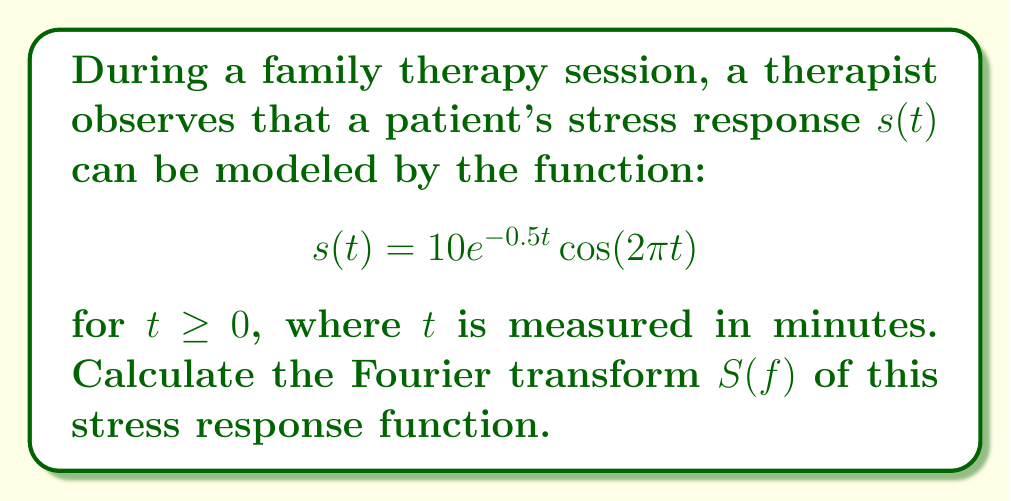Show me your answer to this math problem. To solve this problem, we'll follow these steps:

1) The Fourier transform of a function $s(t)$ is defined as:

   $$S(f) = \int_{-\infty}^{\infty} s(t)e^{-j2\pi ft}dt$$

2) In our case, $s(t)$ is only defined for $t \geq 0$, so we can rewrite the integral as:

   $$S(f) = \int_{0}^{\infty} 10e^{-0.5t}\cos(2\pi t)e^{-j2\pi ft}dt$$

3) We can use Euler's formula to express the cosine term:

   $$\cos(2\pi t) = \frac{1}{2}(e^{j2\pi t} + e^{-j2\pi t})$$

4) Substituting this into our integral:

   $$S(f) = 10\int_{0}^{\infty} e^{-0.5t}\frac{1}{2}(e^{j2\pi t} + e^{-j2\pi t})e^{-j2\pi ft}dt$$

5) Simplifying:

   $$S(f) = 5\int_{0}^{\infty} (e^{-(0.5-j2\pi(1-f))t} + e^{-(0.5+j2\pi(1+f))t})dt$$

6) This integral can be solved using the formula $\int_{0}^{\infty} e^{-at}dt = \frac{1}{a}$ for $Re(a) > 0$:

   $$S(f) = 5[\frac{1}{0.5-j2\pi(1-f)} + \frac{1}{0.5+j2\pi(1+f)}]$$

7) Simplifying and finding a common denominator:

   $$S(f) = \frac{5(1+j4\pi f)}{0.25+(2\pi(1-f))^2} + \frac{5(1-j4\pi f)}{0.25+(2\pi(1+f))^2}$$

This is the Fourier transform of the given stress response function.
Answer: $$S(f) = \frac{5(1+j4\pi f)}{0.25+(2\pi(1-f))^2} + \frac{5(1-j4\pi f)}{0.25+(2\pi(1+f))^2}$$ 